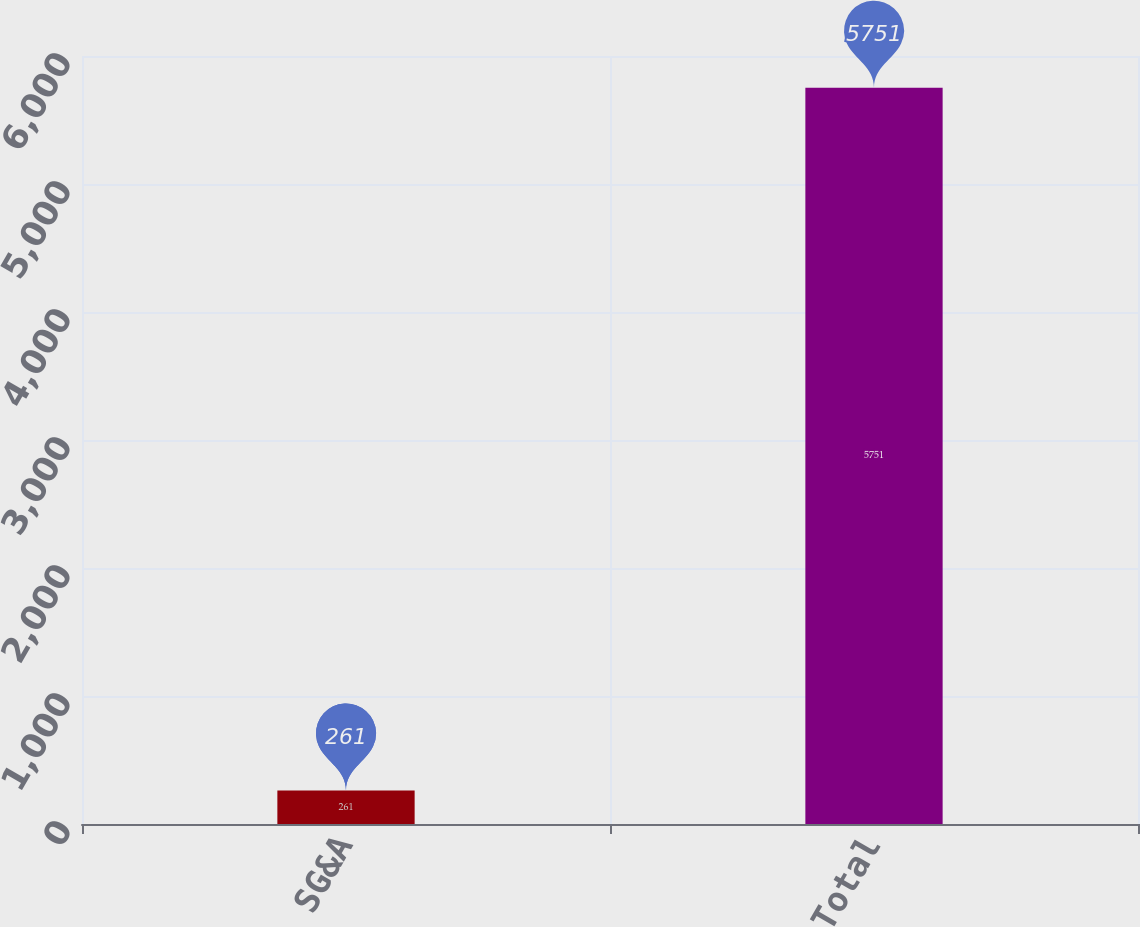Convert chart. <chart><loc_0><loc_0><loc_500><loc_500><bar_chart><fcel>SG&A<fcel>Total<nl><fcel>261<fcel>5751<nl></chart> 